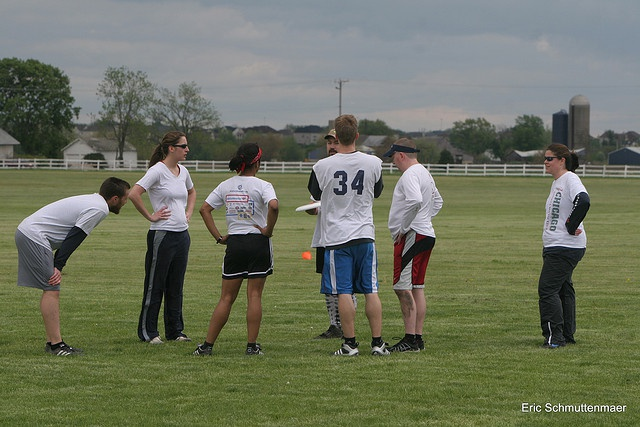Describe the objects in this image and their specific colors. I can see people in darkgray, black, navy, and gray tones, people in darkgray, black, and maroon tones, people in darkgray, black, gray, and lavender tones, people in darkgray, gray, black, and lavender tones, and people in darkgray, black, gray, and lavender tones in this image. 